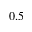<formula> <loc_0><loc_0><loc_500><loc_500>0 . 5</formula> 